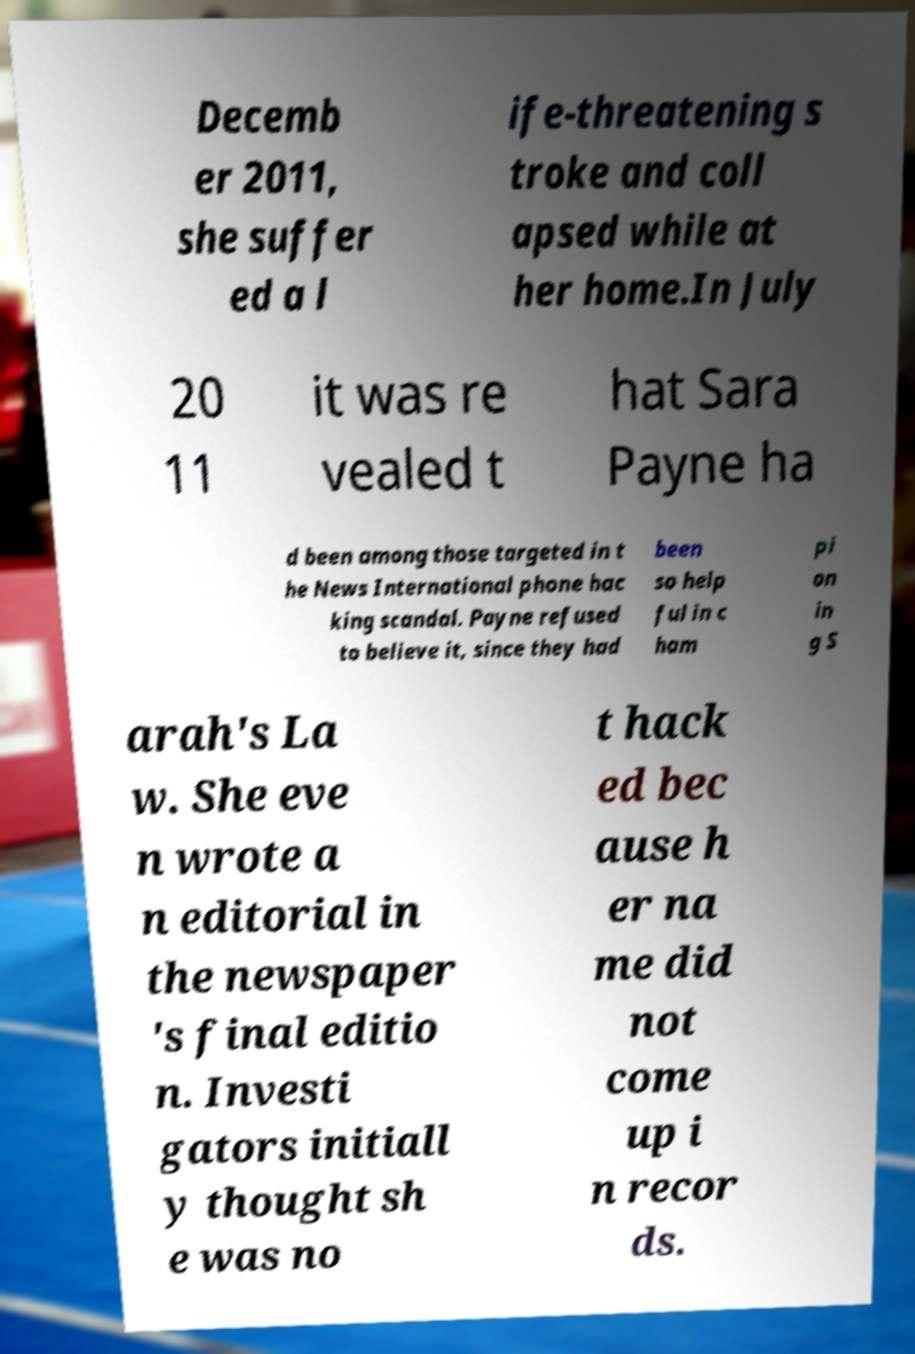What messages or text are displayed in this image? I need them in a readable, typed format. Decemb er 2011, she suffer ed a l ife-threatening s troke and coll apsed while at her home.In July 20 11 it was re vealed t hat Sara Payne ha d been among those targeted in t he News International phone hac king scandal. Payne refused to believe it, since they had been so help ful in c ham pi on in g S arah's La w. She eve n wrote a n editorial in the newspaper 's final editio n. Investi gators initiall y thought sh e was no t hack ed bec ause h er na me did not come up i n recor ds. 